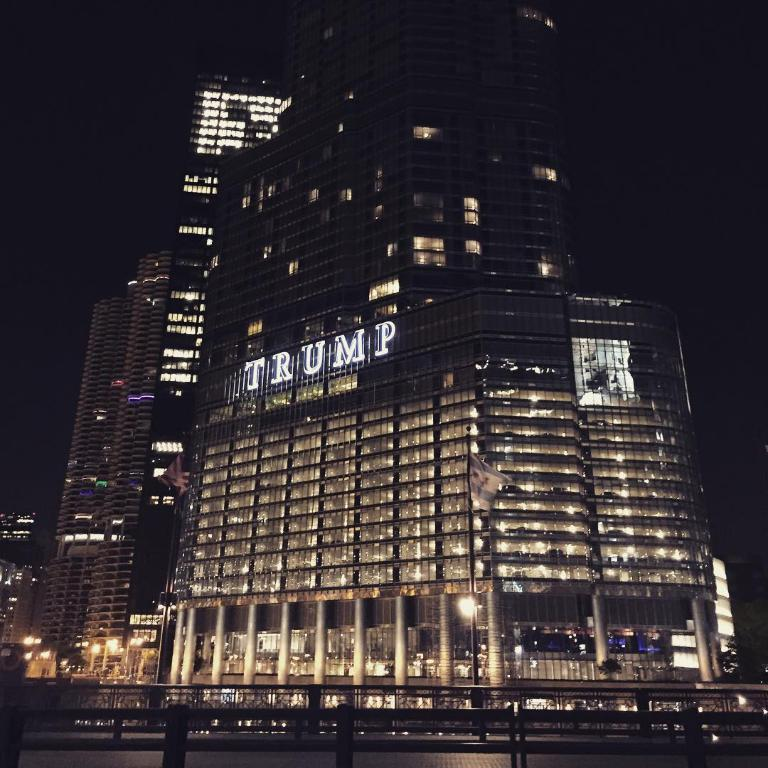<image>
Share a concise interpretation of the image provided. Tall building with the word TRUMP on the front. 